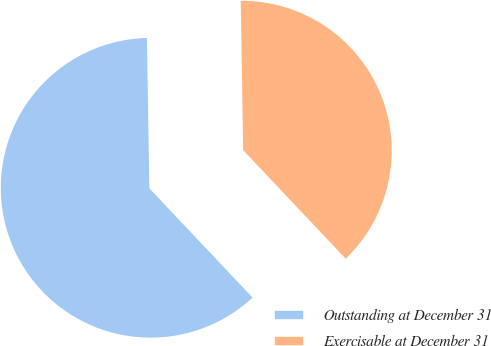Convert chart. <chart><loc_0><loc_0><loc_500><loc_500><pie_chart><fcel>Outstanding at December 31<fcel>Exercisable at December 31<nl><fcel>61.79%<fcel>38.21%<nl></chart> 